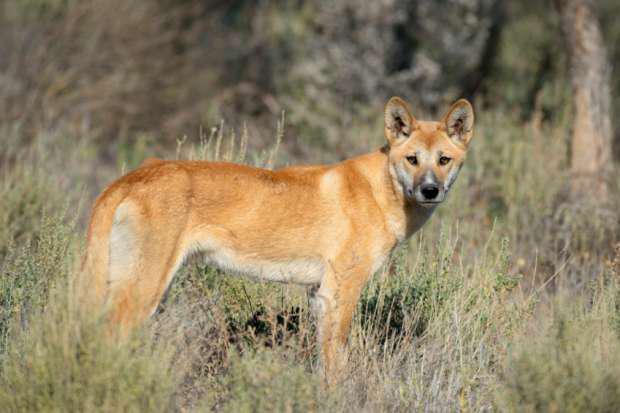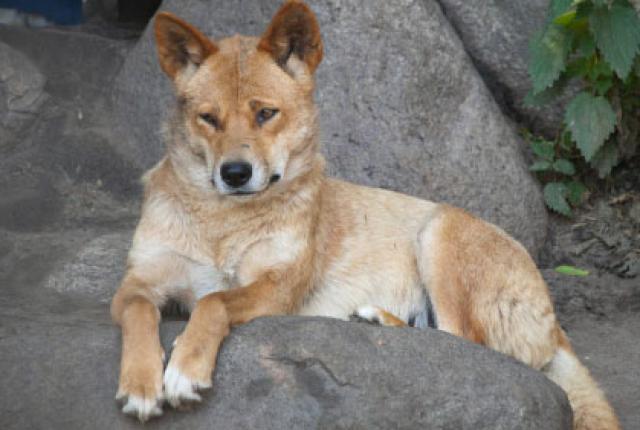The first image is the image on the left, the second image is the image on the right. Considering the images on both sides, is "At least one dog has its teeth visible." valid? Answer yes or no. No. 